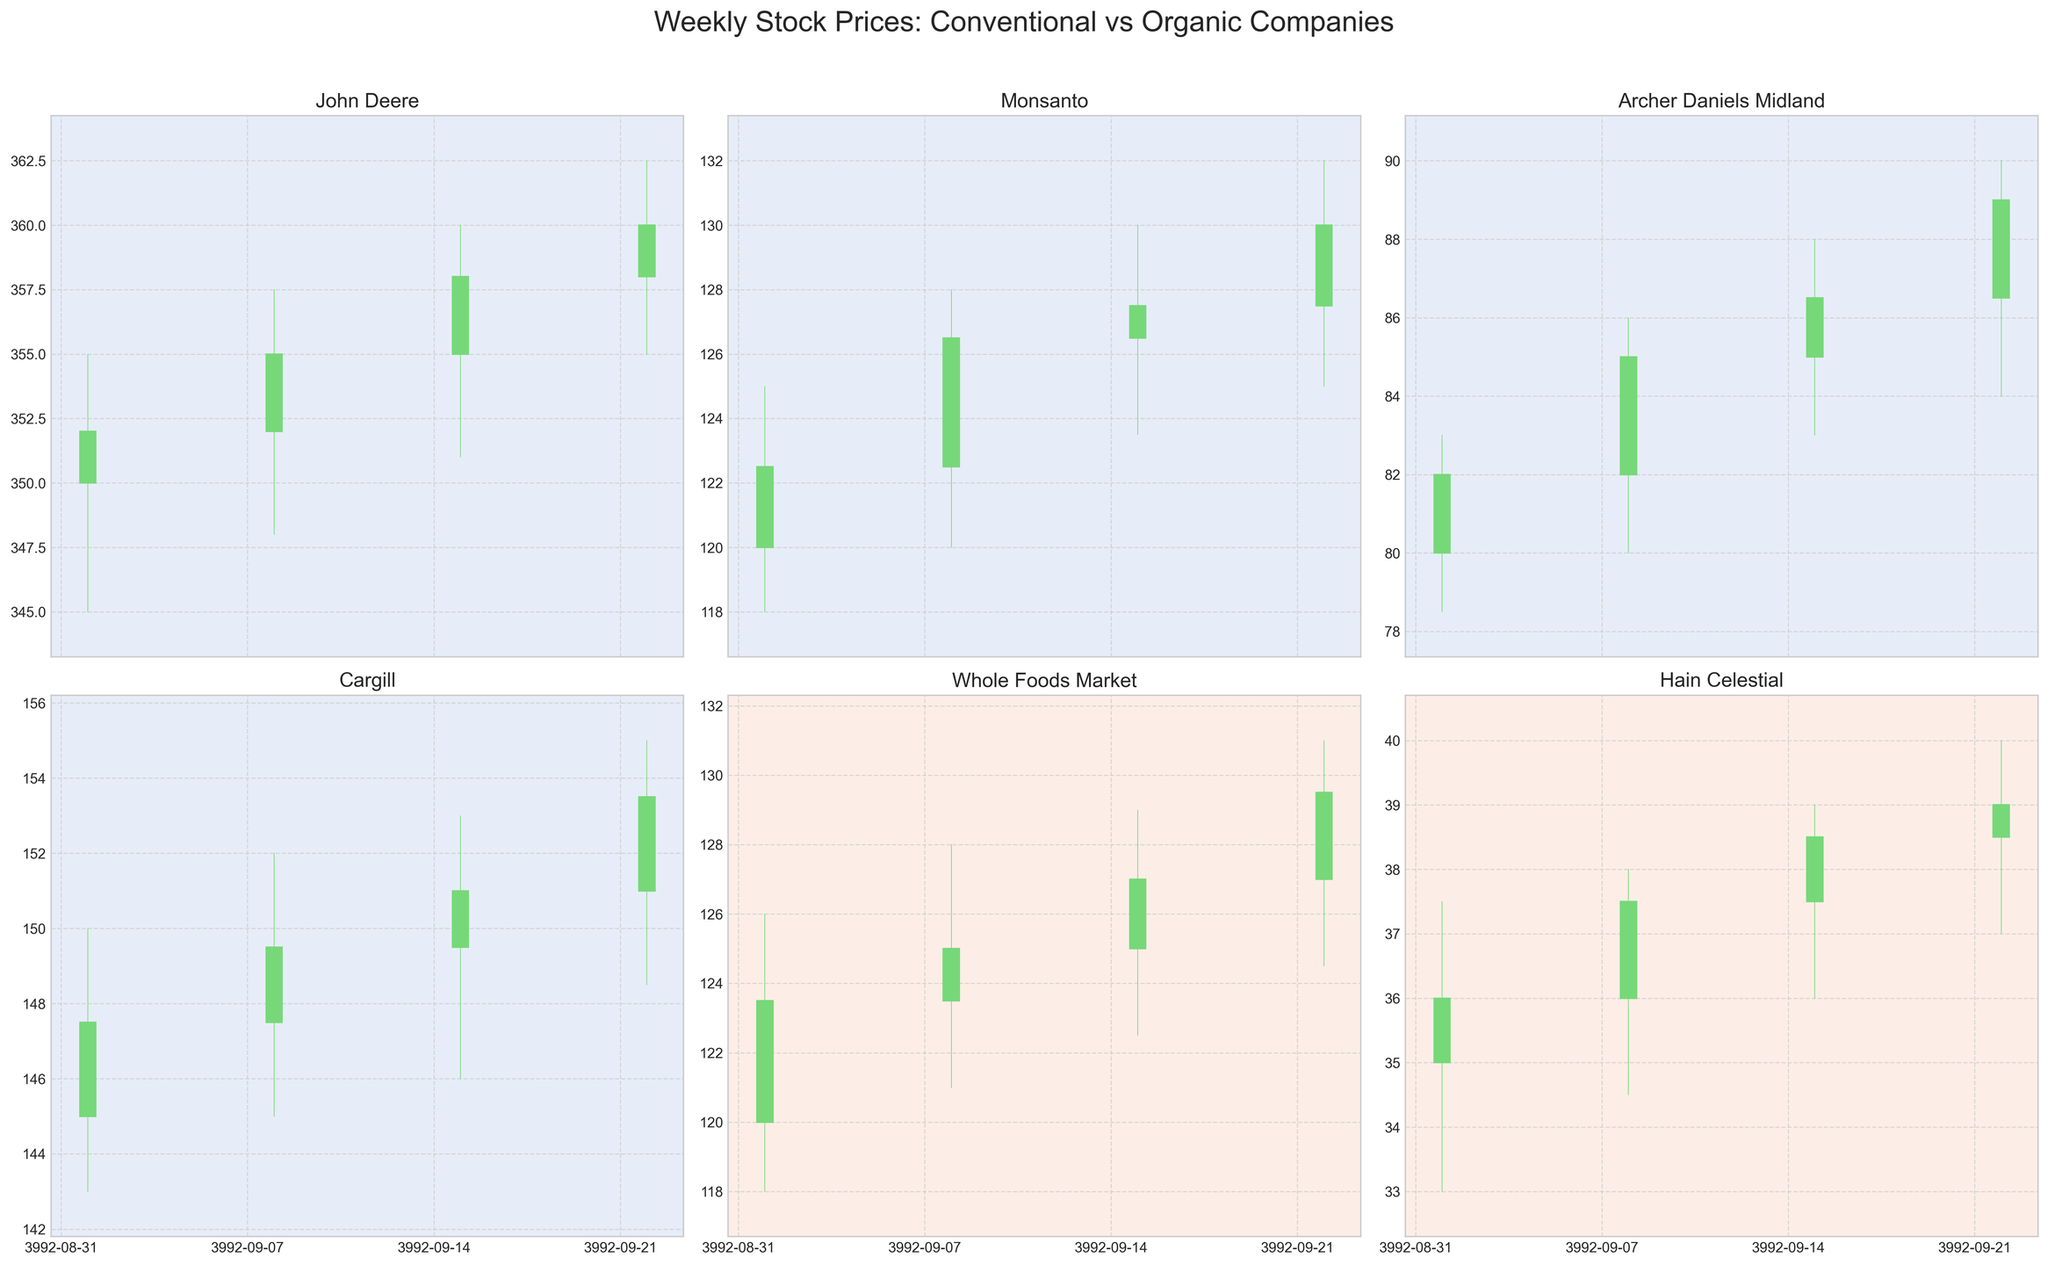What is the highest stock price achieved by Whole Foods Market during the given weeks? Look for the highest value represented by the 'High' points (the top of the candlestick wicks) for Whole Foods Market. The highest recorded value is $131.00 on September 22, 2023.
Answer: $131.00 How many conventional agribusiness companies are compared in the figure? Count the number of conventional agribusiness companies listed in the data under the 'Category' column. There are four such companies: John Deere, Monsanto, Archer Daniels Midland, and Cargill.
Answer: 4 Which company shows the largest increase in stock price from the opening to the closing price on September 08, 2023? Compare the difference between the 'Open' and 'Close' prices for each company on September 08, 2023. John Deere went from $352.00 to $355.00, a $3.00 increase. The other companies' increases are smaller.
Answer: John Deere What is the overall trend for John Deere's stock price during the given weeks? Observe the closing prices of John Deere over the weeks. The prices are $352.00, $355.00, $358.00, and $360.00. Each week shows an increase, indicating an upward trend.
Answer: Upward trend Compare the closing prices of Archer Daniels Midland and Hain Celestial on September 15, 2023. Which one is higher? Check the 'Close' prices for both companies on September 15, 2023. Archer Daniels Midland closed at $86.50, while Hain Celestial closed at $38.50. Archer Daniels Midland's closing price is higher.
Answer: Archer Daniels Midland What is the average closing price of Monsanto over the given weeks? Sum the closing prices of Monsanto for each week and divide by the number of weeks: (122.50 + 126.50 + 127.50 + 130.00) / 4 = 506.50 / 4. The average closing price is $126.625.
Answer: $126.625 Which company had the highest trading volume on September 15, 2023? Compare the 'Volume' values for each company on September 15, 2023. John Deere had the highest volume at 1,350,000.
Answer: John Deere How does the price range (difference between high and low) of Whole Foods Market on September 01, 2023, compare to September 22, 2023? Calculate the difference between 'High' and 'Low' on both dates: September 01: $126.00 - $118.00 = $8.00, September 22: $131.00 - $124.50 = $6.50. The price range on September 01, 2023, is larger.
Answer: September 01 has a larger range 